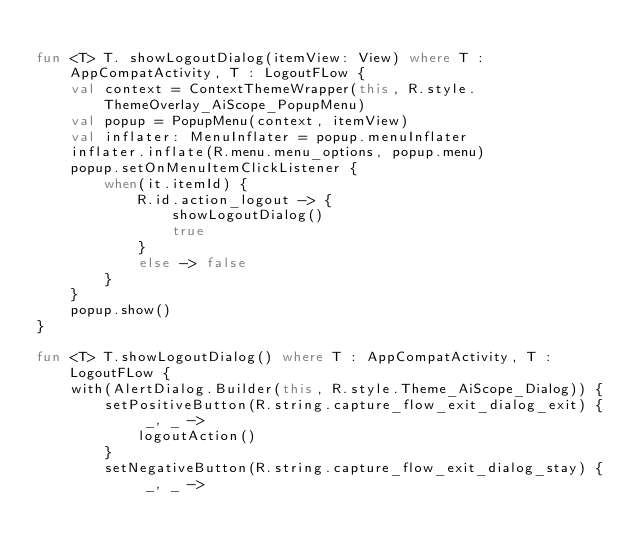<code> <loc_0><loc_0><loc_500><loc_500><_Kotlin_>
fun <T> T. showLogoutDialog(itemView: View) where T : AppCompatActivity, T : LogoutFLow {
    val context = ContextThemeWrapper(this, R.style.ThemeOverlay_AiScope_PopupMenu)
    val popup = PopupMenu(context, itemView)
    val inflater: MenuInflater = popup.menuInflater
    inflater.inflate(R.menu.menu_options, popup.menu)
    popup.setOnMenuItemClickListener {
        when(it.itemId) {
            R.id.action_logout -> {
                showLogoutDialog()
                true
            }
            else -> false
        }
    }
    popup.show()
}

fun <T> T.showLogoutDialog() where T : AppCompatActivity, T : LogoutFLow {
    with(AlertDialog.Builder(this, R.style.Theme_AiScope_Dialog)) {
        setPositiveButton(R.string.capture_flow_exit_dialog_exit) { _, _ ->
            logoutAction()
        }
        setNegativeButton(R.string.capture_flow_exit_dialog_stay) { _, _ -></code> 